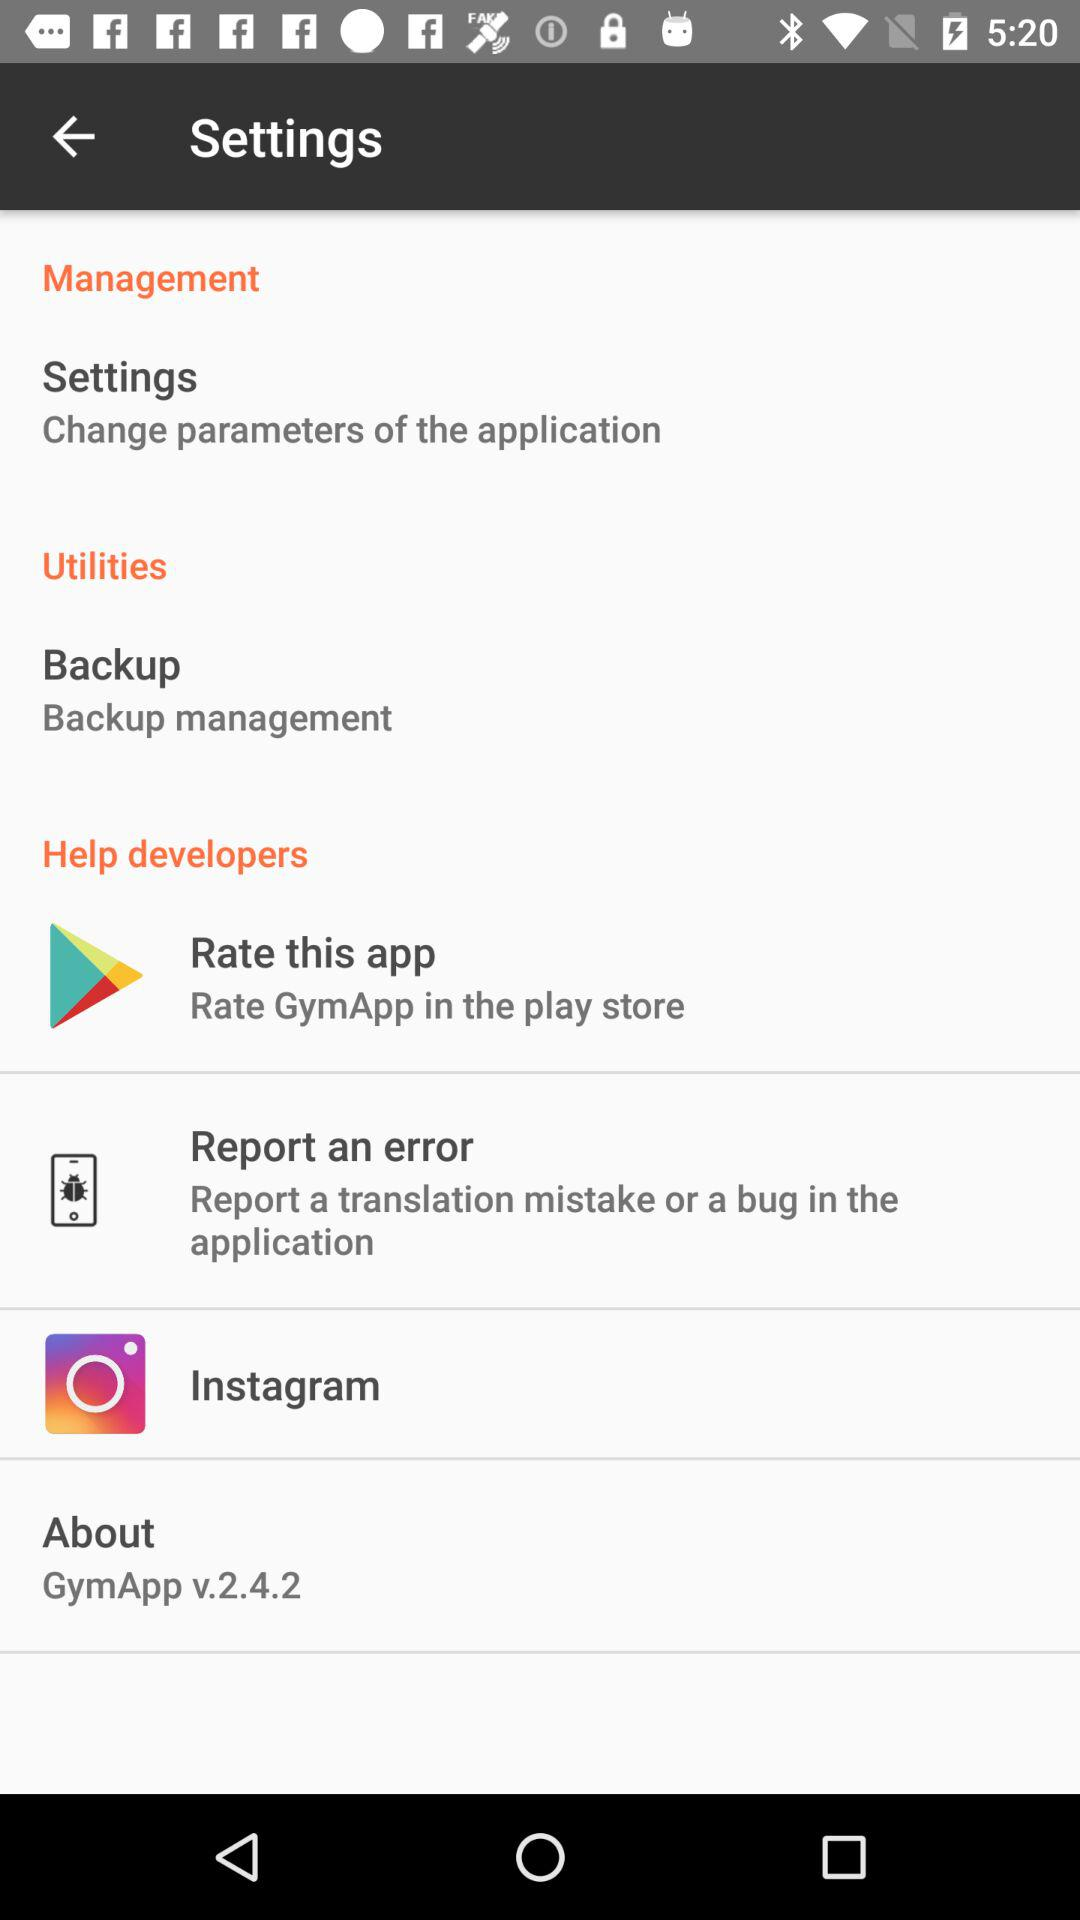How many stars does "GymApp" have?
When the provided information is insufficient, respond with <no answer>. <no answer> 